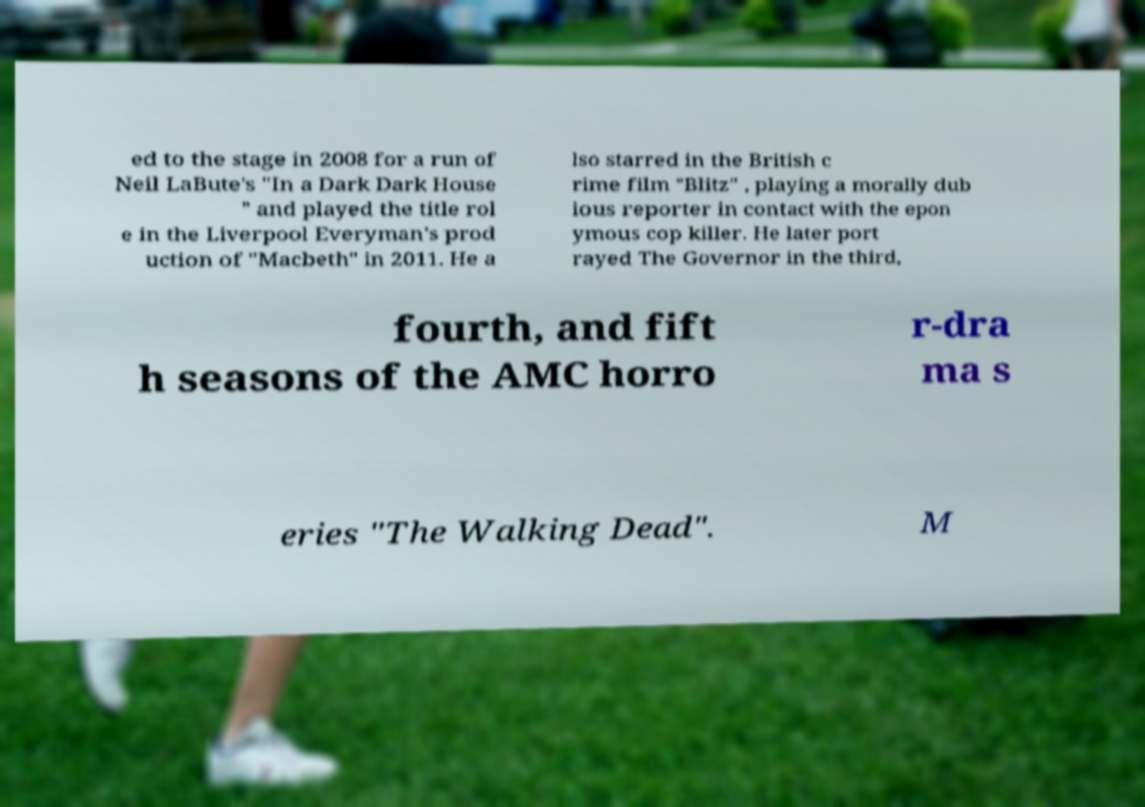Can you read and provide the text displayed in the image?This photo seems to have some interesting text. Can you extract and type it out for me? ed to the stage in 2008 for a run of Neil LaBute's "In a Dark Dark House " and played the title rol e in the Liverpool Everyman's prod uction of "Macbeth" in 2011. He a lso starred in the British c rime film "Blitz" , playing a morally dub ious reporter in contact with the epon ymous cop killer. He later port rayed The Governor in the third, fourth, and fift h seasons of the AMC horro r-dra ma s eries "The Walking Dead". M 